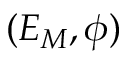Convert formula to latex. <formula><loc_0><loc_0><loc_500><loc_500>( E _ { M } , \phi )</formula> 